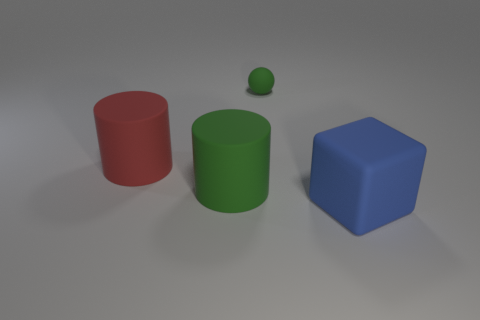Add 2 blue objects. How many objects exist? 6 Subtract all balls. How many objects are left? 3 Add 3 green rubber balls. How many green rubber balls exist? 4 Subtract 0 gray cubes. How many objects are left? 4 Subtract all big blue matte cubes. Subtract all tiny matte things. How many objects are left? 2 Add 4 matte cubes. How many matte cubes are left? 5 